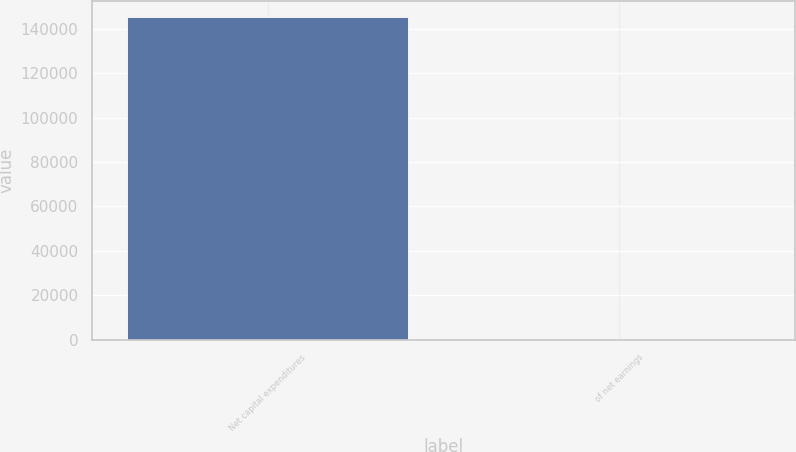<chart> <loc_0><loc_0><loc_500><loc_500><bar_chart><fcel>Net capital expenditures<fcel>of net earnings<nl><fcel>145227<fcel>28.1<nl></chart> 